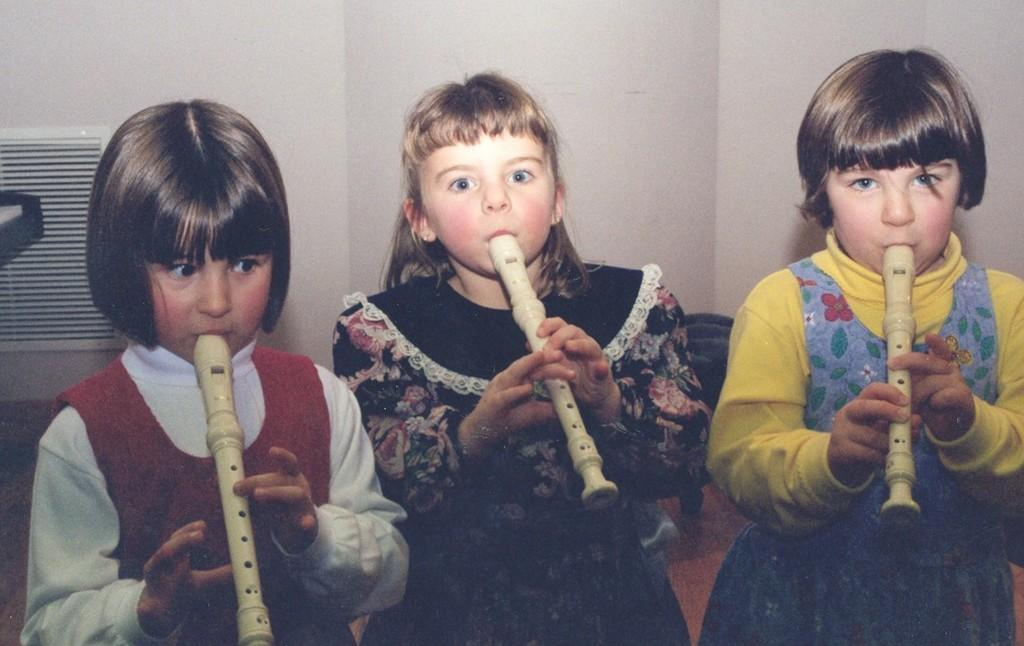How many people are in the image? There are three girls in the image. What are the girls doing in the image? The girls are standing and playing the flute. What type of shade is covering the girls in the image? There is no shade visible in the image; the girls are not covered by any shade. What material is the brick wall behind the girls made of? There is no brick wall visible in the image; the background is not described in the provided facts. 